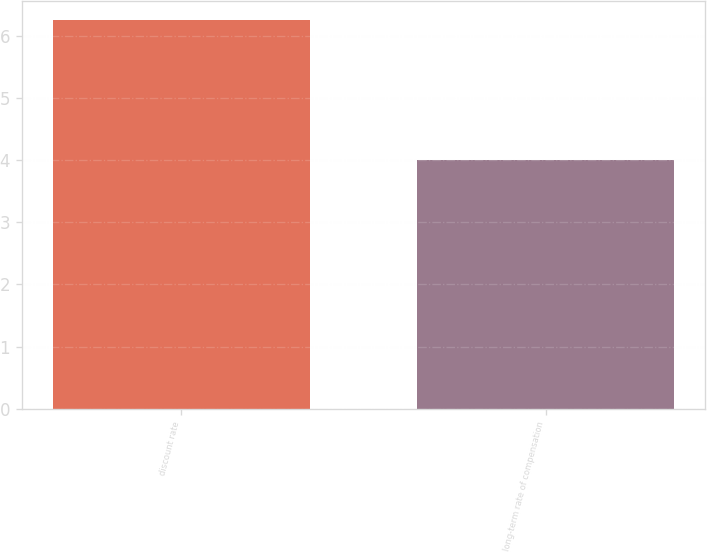Convert chart to OTSL. <chart><loc_0><loc_0><loc_500><loc_500><bar_chart><fcel>discount rate<fcel>long-term rate of compensation<nl><fcel>6.25<fcel>4<nl></chart> 